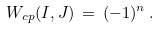Convert formula to latex. <formula><loc_0><loc_0><loc_500><loc_500>W _ { c p } ( I , J ) \, = \, ( - 1 ) ^ { n } \, .</formula> 